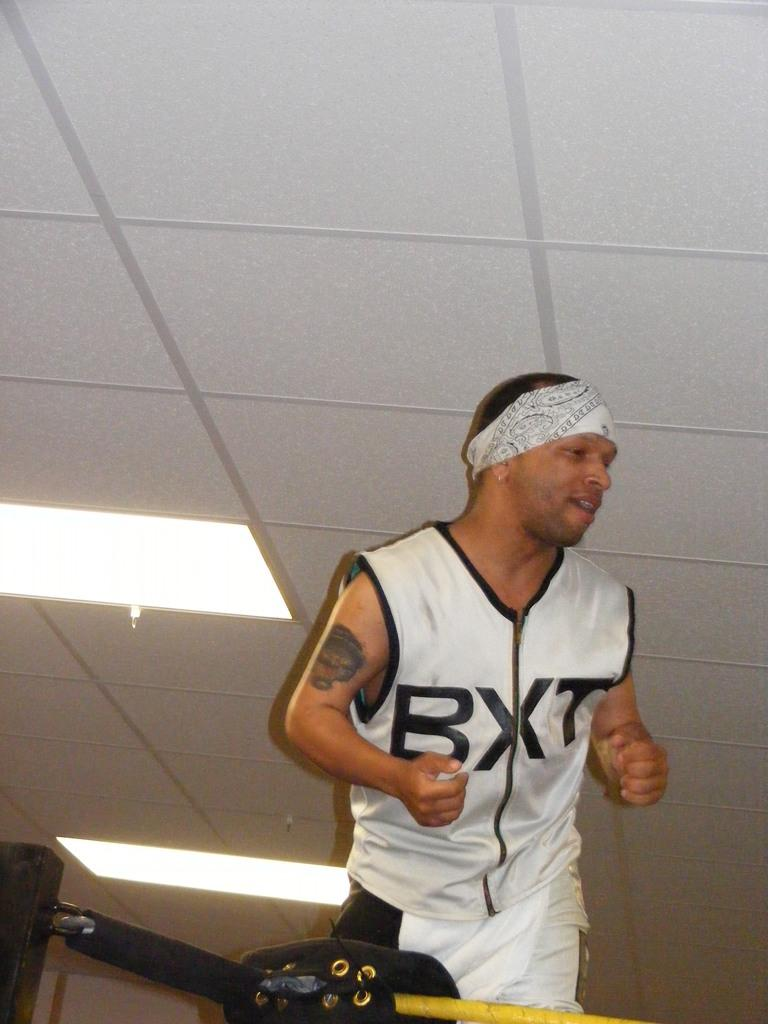<image>
Give a short and clear explanation of the subsequent image. A man is working out in a boxing ring and wearing a shirt with the letters BXT. 